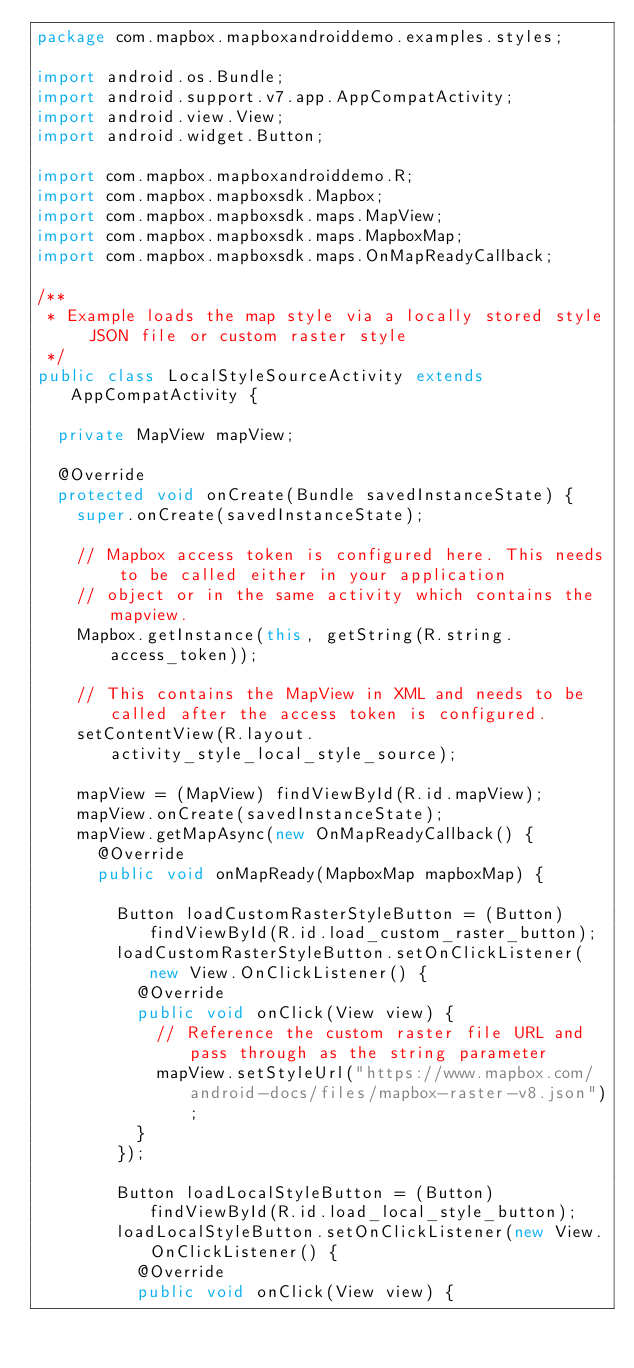<code> <loc_0><loc_0><loc_500><loc_500><_Java_>package com.mapbox.mapboxandroiddemo.examples.styles;

import android.os.Bundle;
import android.support.v7.app.AppCompatActivity;
import android.view.View;
import android.widget.Button;

import com.mapbox.mapboxandroiddemo.R;
import com.mapbox.mapboxsdk.Mapbox;
import com.mapbox.mapboxsdk.maps.MapView;
import com.mapbox.mapboxsdk.maps.MapboxMap;
import com.mapbox.mapboxsdk.maps.OnMapReadyCallback;

/**
 * Example loads the map style via a locally stored style JSON file or custom raster style
 */
public class LocalStyleSourceActivity extends AppCompatActivity {

  private MapView mapView;

  @Override
  protected void onCreate(Bundle savedInstanceState) {
    super.onCreate(savedInstanceState);

    // Mapbox access token is configured here. This needs to be called either in your application
    // object or in the same activity which contains the mapview.
    Mapbox.getInstance(this, getString(R.string.access_token));

    // This contains the MapView in XML and needs to be called after the access token is configured.
    setContentView(R.layout.activity_style_local_style_source);

    mapView = (MapView) findViewById(R.id.mapView);
    mapView.onCreate(savedInstanceState);
    mapView.getMapAsync(new OnMapReadyCallback() {
      @Override
      public void onMapReady(MapboxMap mapboxMap) {

        Button loadCustomRasterStyleButton = (Button) findViewById(R.id.load_custom_raster_button);
        loadCustomRasterStyleButton.setOnClickListener(new View.OnClickListener() {
          @Override
          public void onClick(View view) {
            // Reference the custom raster file URL and pass through as the string parameter
            mapView.setStyleUrl("https://www.mapbox.com/android-docs/files/mapbox-raster-v8.json");
          }
        });

        Button loadLocalStyleButton = (Button) findViewById(R.id.load_local_style_button);
        loadLocalStyleButton.setOnClickListener(new View.OnClickListener() {
          @Override
          public void onClick(View view) {</code> 